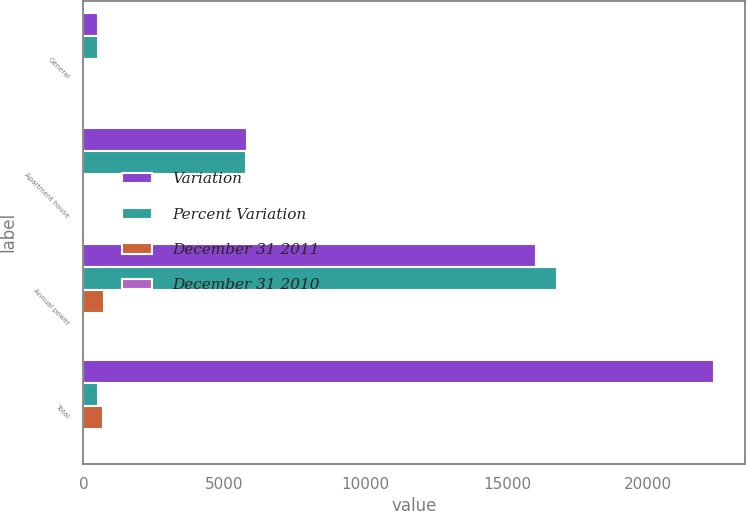Convert chart to OTSL. <chart><loc_0><loc_0><loc_500><loc_500><stacked_bar_chart><ecel><fcel>General<fcel>Apartment house<fcel>Annual power<fcel>Total<nl><fcel>Variation<fcel>519<fcel>5779<fcel>16024<fcel>22322<nl><fcel>Percent Variation<fcel>515<fcel>5748<fcel>16767<fcel>519<nl><fcel>December 31 2011<fcel>4<fcel>31<fcel>743<fcel>708<nl><fcel>December 31 2010<fcel>0.8<fcel>0.5<fcel>4.4<fcel>3.1<nl></chart> 